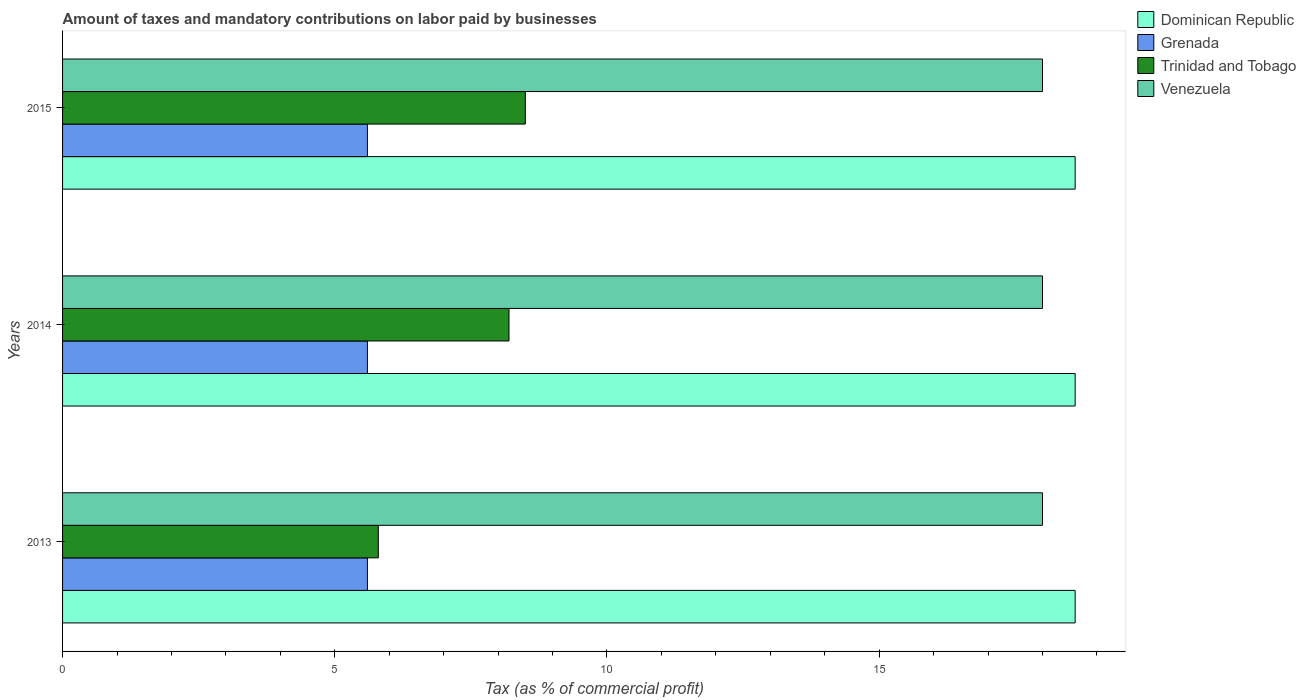How many different coloured bars are there?
Give a very brief answer. 4. Are the number of bars per tick equal to the number of legend labels?
Ensure brevity in your answer.  Yes. Are the number of bars on each tick of the Y-axis equal?
Your answer should be compact. Yes. How many bars are there on the 1st tick from the top?
Provide a succinct answer. 4. What is the label of the 2nd group of bars from the top?
Provide a short and direct response. 2014. In how many cases, is the number of bars for a given year not equal to the number of legend labels?
Offer a terse response. 0. What is the percentage of taxes paid by businesses in Trinidad and Tobago in 2015?
Provide a short and direct response. 8.5. In which year was the percentage of taxes paid by businesses in Grenada maximum?
Provide a short and direct response. 2013. What is the total percentage of taxes paid by businesses in Venezuela in the graph?
Make the answer very short. 54. What is the difference between the percentage of taxes paid by businesses in Grenada in 2013 and that in 2015?
Offer a very short reply. 0. What is the difference between the percentage of taxes paid by businesses in Trinidad and Tobago in 2013 and the percentage of taxes paid by businesses in Grenada in 2015?
Provide a succinct answer. 0.2. In the year 2014, what is the difference between the percentage of taxes paid by businesses in Dominican Republic and percentage of taxes paid by businesses in Venezuela?
Offer a terse response. 0.6. What is the ratio of the percentage of taxes paid by businesses in Trinidad and Tobago in 2013 to that in 2014?
Provide a succinct answer. 0.71. Is the percentage of taxes paid by businesses in Trinidad and Tobago in 2013 less than that in 2014?
Your answer should be compact. Yes. What is the difference between the highest and the second highest percentage of taxes paid by businesses in Venezuela?
Ensure brevity in your answer.  0. In how many years, is the percentage of taxes paid by businesses in Grenada greater than the average percentage of taxes paid by businesses in Grenada taken over all years?
Your answer should be very brief. 3. Is the sum of the percentage of taxes paid by businesses in Dominican Republic in 2014 and 2015 greater than the maximum percentage of taxes paid by businesses in Grenada across all years?
Your response must be concise. Yes. Is it the case that in every year, the sum of the percentage of taxes paid by businesses in Dominican Republic and percentage of taxes paid by businesses in Grenada is greater than the sum of percentage of taxes paid by businesses in Trinidad and Tobago and percentage of taxes paid by businesses in Venezuela?
Give a very brief answer. No. What does the 3rd bar from the top in 2013 represents?
Provide a short and direct response. Grenada. What does the 2nd bar from the bottom in 2014 represents?
Give a very brief answer. Grenada. How many years are there in the graph?
Give a very brief answer. 3. Are the values on the major ticks of X-axis written in scientific E-notation?
Your answer should be very brief. No. Does the graph contain any zero values?
Offer a terse response. No. Does the graph contain grids?
Ensure brevity in your answer.  No. How many legend labels are there?
Provide a succinct answer. 4. What is the title of the graph?
Provide a short and direct response. Amount of taxes and mandatory contributions on labor paid by businesses. What is the label or title of the X-axis?
Your response must be concise. Tax (as % of commercial profit). What is the Tax (as % of commercial profit) of Grenada in 2013?
Offer a terse response. 5.6. What is the Tax (as % of commercial profit) in Trinidad and Tobago in 2013?
Give a very brief answer. 5.8. What is the Tax (as % of commercial profit) in Venezuela in 2013?
Keep it short and to the point. 18. What is the Tax (as % of commercial profit) of Dominican Republic in 2014?
Your answer should be very brief. 18.6. What is the Tax (as % of commercial profit) in Grenada in 2014?
Your response must be concise. 5.6. What is the Tax (as % of commercial profit) in Trinidad and Tobago in 2014?
Your answer should be very brief. 8.2. What is the Tax (as % of commercial profit) of Dominican Republic in 2015?
Offer a terse response. 18.6. What is the Tax (as % of commercial profit) of Trinidad and Tobago in 2015?
Keep it short and to the point. 8.5. What is the Tax (as % of commercial profit) in Venezuela in 2015?
Provide a short and direct response. 18. Across all years, what is the maximum Tax (as % of commercial profit) of Dominican Republic?
Ensure brevity in your answer.  18.6. Across all years, what is the maximum Tax (as % of commercial profit) in Venezuela?
Keep it short and to the point. 18. Across all years, what is the minimum Tax (as % of commercial profit) in Trinidad and Tobago?
Offer a very short reply. 5.8. Across all years, what is the minimum Tax (as % of commercial profit) in Venezuela?
Your answer should be compact. 18. What is the total Tax (as % of commercial profit) of Dominican Republic in the graph?
Your answer should be very brief. 55.8. What is the total Tax (as % of commercial profit) of Trinidad and Tobago in the graph?
Offer a terse response. 22.5. What is the difference between the Tax (as % of commercial profit) in Venezuela in 2013 and that in 2014?
Your answer should be compact. 0. What is the difference between the Tax (as % of commercial profit) of Trinidad and Tobago in 2013 and that in 2015?
Your response must be concise. -2.7. What is the difference between the Tax (as % of commercial profit) in Dominican Republic in 2014 and that in 2015?
Offer a terse response. 0. What is the difference between the Tax (as % of commercial profit) in Grenada in 2014 and that in 2015?
Your response must be concise. 0. What is the difference between the Tax (as % of commercial profit) in Trinidad and Tobago in 2014 and that in 2015?
Keep it short and to the point. -0.3. What is the difference between the Tax (as % of commercial profit) of Venezuela in 2014 and that in 2015?
Offer a terse response. 0. What is the difference between the Tax (as % of commercial profit) of Dominican Republic in 2013 and the Tax (as % of commercial profit) of Venezuela in 2014?
Make the answer very short. 0.6. What is the difference between the Tax (as % of commercial profit) of Grenada in 2013 and the Tax (as % of commercial profit) of Venezuela in 2014?
Keep it short and to the point. -12.4. What is the difference between the Tax (as % of commercial profit) of Dominican Republic in 2013 and the Tax (as % of commercial profit) of Venezuela in 2015?
Offer a terse response. 0.6. What is the difference between the Tax (as % of commercial profit) in Grenada in 2013 and the Tax (as % of commercial profit) in Trinidad and Tobago in 2015?
Your answer should be very brief. -2.9. What is the difference between the Tax (as % of commercial profit) of Trinidad and Tobago in 2013 and the Tax (as % of commercial profit) of Venezuela in 2015?
Provide a short and direct response. -12.2. What is the difference between the Tax (as % of commercial profit) of Dominican Republic in 2014 and the Tax (as % of commercial profit) of Trinidad and Tobago in 2015?
Offer a very short reply. 10.1. What is the average Tax (as % of commercial profit) in Grenada per year?
Keep it short and to the point. 5.6. In the year 2013, what is the difference between the Tax (as % of commercial profit) in Dominican Republic and Tax (as % of commercial profit) in Grenada?
Give a very brief answer. 13. In the year 2013, what is the difference between the Tax (as % of commercial profit) of Dominican Republic and Tax (as % of commercial profit) of Trinidad and Tobago?
Your answer should be very brief. 12.8. In the year 2013, what is the difference between the Tax (as % of commercial profit) in Dominican Republic and Tax (as % of commercial profit) in Venezuela?
Your response must be concise. 0.6. In the year 2013, what is the difference between the Tax (as % of commercial profit) in Grenada and Tax (as % of commercial profit) in Trinidad and Tobago?
Give a very brief answer. -0.2. In the year 2013, what is the difference between the Tax (as % of commercial profit) in Grenada and Tax (as % of commercial profit) in Venezuela?
Offer a terse response. -12.4. In the year 2013, what is the difference between the Tax (as % of commercial profit) of Trinidad and Tobago and Tax (as % of commercial profit) of Venezuela?
Your response must be concise. -12.2. In the year 2014, what is the difference between the Tax (as % of commercial profit) in Dominican Republic and Tax (as % of commercial profit) in Trinidad and Tobago?
Make the answer very short. 10.4. In the year 2015, what is the difference between the Tax (as % of commercial profit) in Dominican Republic and Tax (as % of commercial profit) in Venezuela?
Provide a succinct answer. 0.6. In the year 2015, what is the difference between the Tax (as % of commercial profit) of Grenada and Tax (as % of commercial profit) of Venezuela?
Offer a terse response. -12.4. In the year 2015, what is the difference between the Tax (as % of commercial profit) in Trinidad and Tobago and Tax (as % of commercial profit) in Venezuela?
Your answer should be very brief. -9.5. What is the ratio of the Tax (as % of commercial profit) of Trinidad and Tobago in 2013 to that in 2014?
Your answer should be very brief. 0.71. What is the ratio of the Tax (as % of commercial profit) in Dominican Republic in 2013 to that in 2015?
Offer a very short reply. 1. What is the ratio of the Tax (as % of commercial profit) in Trinidad and Tobago in 2013 to that in 2015?
Provide a succinct answer. 0.68. What is the ratio of the Tax (as % of commercial profit) in Venezuela in 2013 to that in 2015?
Give a very brief answer. 1. What is the ratio of the Tax (as % of commercial profit) in Trinidad and Tobago in 2014 to that in 2015?
Provide a succinct answer. 0.96. What is the difference between the highest and the second highest Tax (as % of commercial profit) in Grenada?
Keep it short and to the point. 0. What is the difference between the highest and the second highest Tax (as % of commercial profit) of Venezuela?
Your response must be concise. 0. What is the difference between the highest and the lowest Tax (as % of commercial profit) in Dominican Republic?
Keep it short and to the point. 0. What is the difference between the highest and the lowest Tax (as % of commercial profit) in Grenada?
Offer a very short reply. 0. What is the difference between the highest and the lowest Tax (as % of commercial profit) in Trinidad and Tobago?
Provide a short and direct response. 2.7. What is the difference between the highest and the lowest Tax (as % of commercial profit) in Venezuela?
Offer a terse response. 0. 